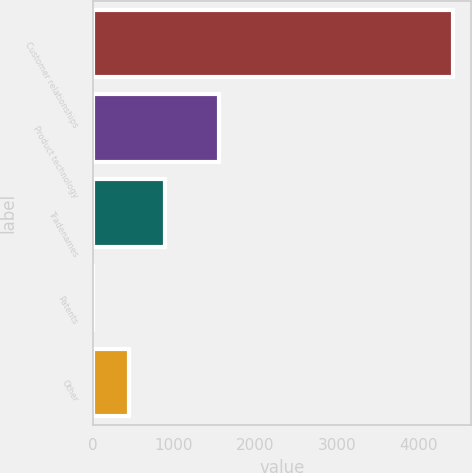Convert chart. <chart><loc_0><loc_0><loc_500><loc_500><bar_chart><fcel>Customer relationships<fcel>Product technology<fcel>Tradenames<fcel>Patents<fcel>Other<nl><fcel>4429.4<fcel>1554.3<fcel>886.28<fcel>0.5<fcel>443.39<nl></chart> 